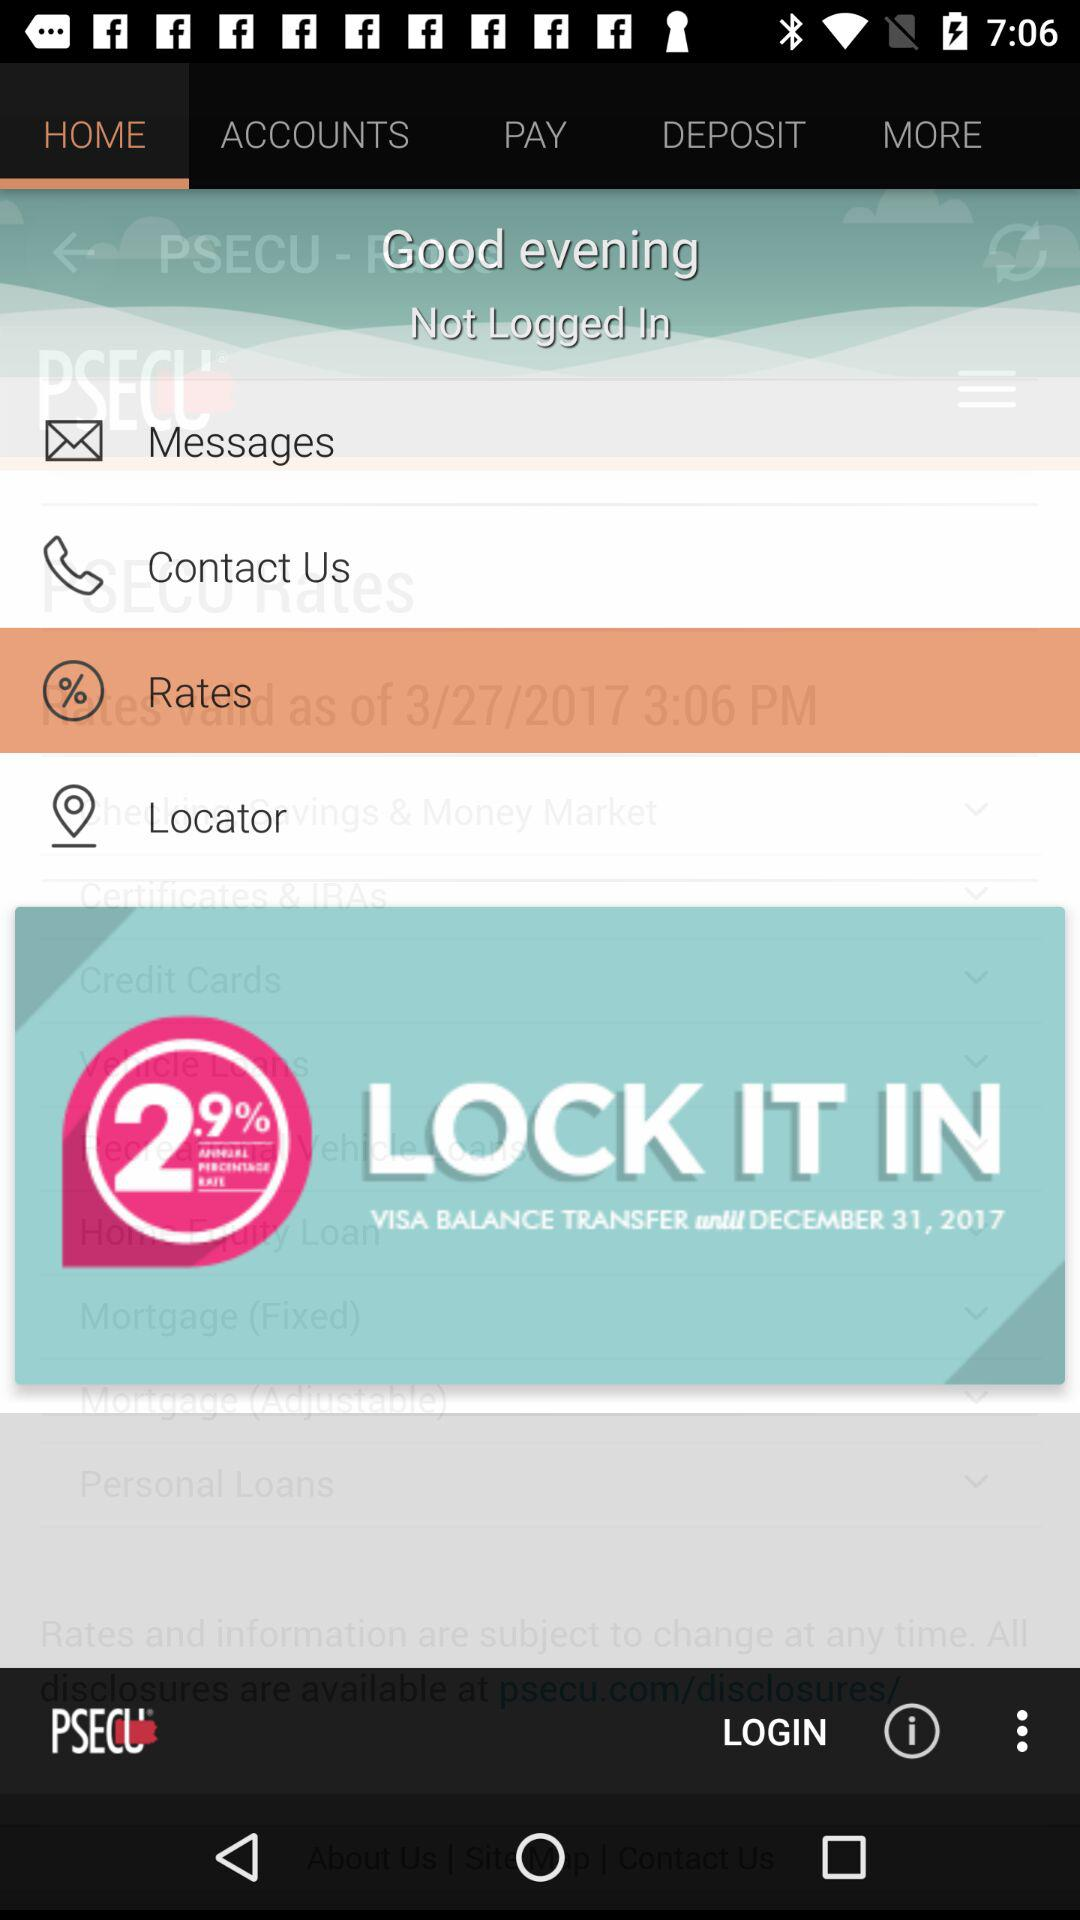What is the mentioned date for "Visa balance transfer"? The date is December 31, 2017. 